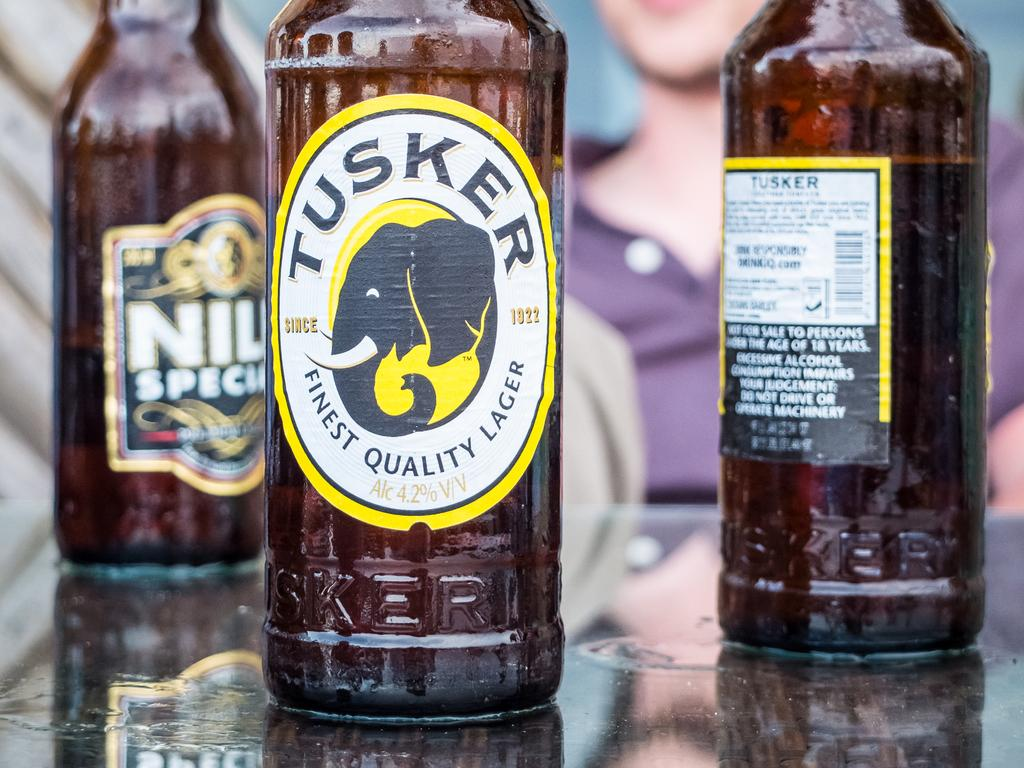Provide a one-sentence caption for the provided image. Three lager bottles, one with Tusker written on it. 